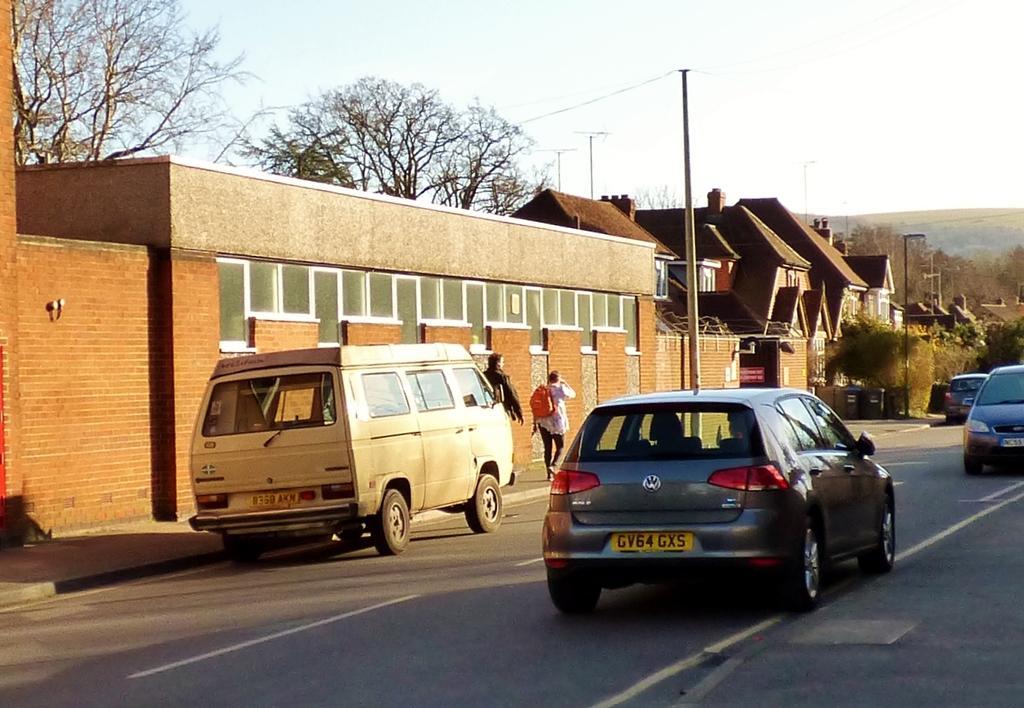In one or two sentences, can you explain what this image depicts? In the foreground of this image, there are few vehicles on the road. In the middle, there are two people walking on the side path. We can also see few poles, buildings, trees and the sky. 